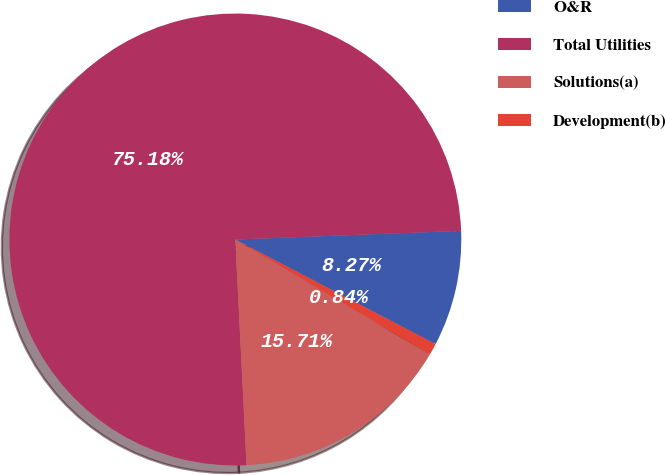<chart> <loc_0><loc_0><loc_500><loc_500><pie_chart><fcel>O&R<fcel>Total Utilities<fcel>Solutions(a)<fcel>Development(b)<nl><fcel>8.27%<fcel>75.19%<fcel>15.71%<fcel>0.84%<nl></chart> 